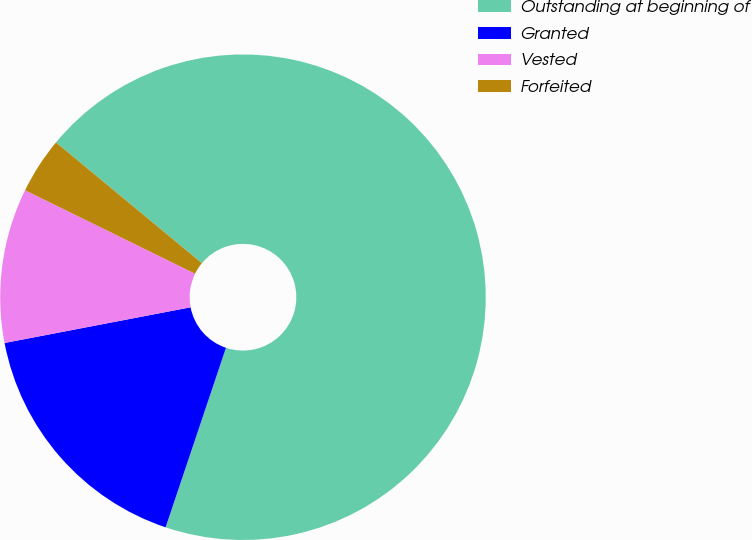Convert chart. <chart><loc_0><loc_0><loc_500><loc_500><pie_chart><fcel>Outstanding at beginning of<fcel>Granted<fcel>Vested<fcel>Forfeited<nl><fcel>69.15%<fcel>16.82%<fcel>10.28%<fcel>3.74%<nl></chart> 